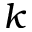<formula> <loc_0><loc_0><loc_500><loc_500>k</formula> 